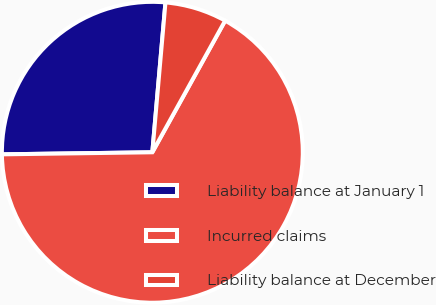Convert chart. <chart><loc_0><loc_0><loc_500><loc_500><pie_chart><fcel>Liability balance at January 1<fcel>Incurred claims<fcel>Liability balance at December<nl><fcel>26.61%<fcel>66.74%<fcel>6.65%<nl></chart> 